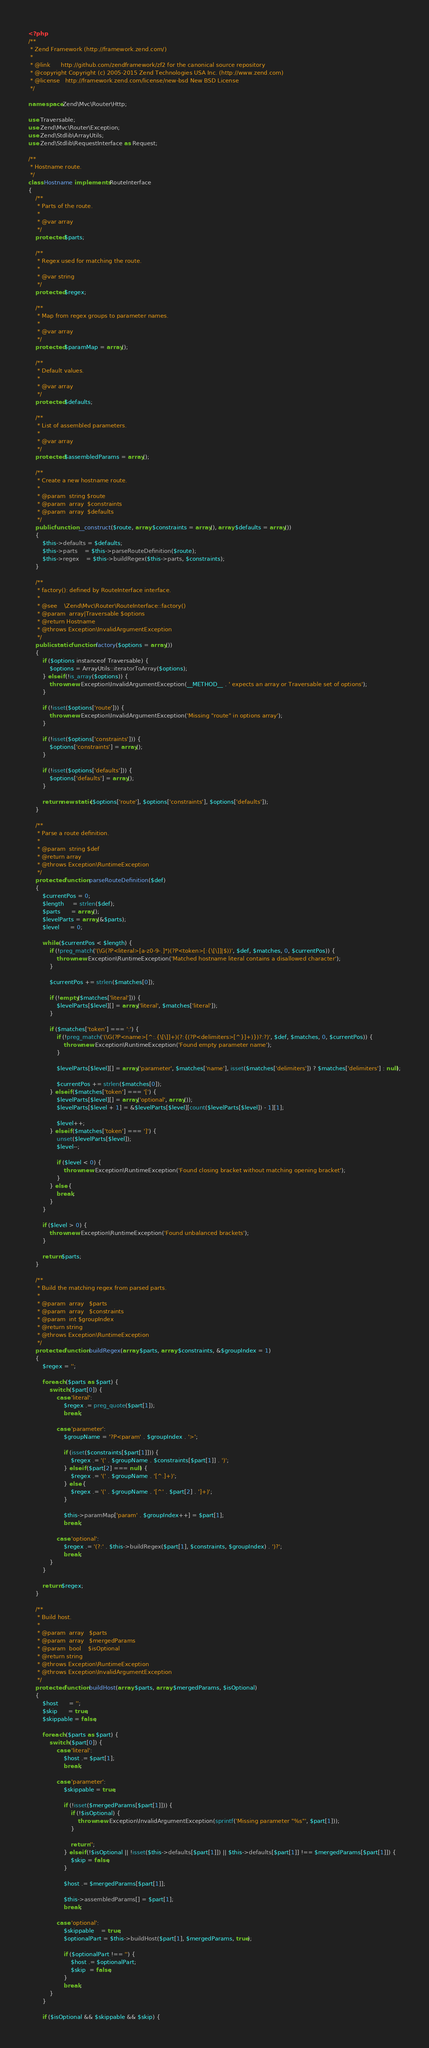<code> <loc_0><loc_0><loc_500><loc_500><_PHP_><?php
/**
 * Zend Framework (http://framework.zend.com/)
 *
 * @link      http://github.com/zendframework/zf2 for the canonical source repository
 * @copyright Copyright (c) 2005-2015 Zend Technologies USA Inc. (http://www.zend.com)
 * @license   http://framework.zend.com/license/new-bsd New BSD License
 */

namespace Zend\Mvc\Router\Http;

use Traversable;
use Zend\Mvc\Router\Exception;
use Zend\Stdlib\ArrayUtils;
use Zend\Stdlib\RequestInterface as Request;

/**
 * Hostname route.
 */
class Hostname implements RouteInterface
{
    /**
     * Parts of the route.
     *
     * @var array
     */
    protected $parts;

    /**
     * Regex used for matching the route.
     *
     * @var string
     */
    protected $regex;

    /**
     * Map from regex groups to parameter names.
     *
     * @var array
     */
    protected $paramMap = array();

    /**
     * Default values.
     *
     * @var array
     */
    protected $defaults;

    /**
     * List of assembled parameters.
     *
     * @var array
     */
    protected $assembledParams = array();

    /**
     * Create a new hostname route.
     *
     * @param  string $route
     * @param  array  $constraints
     * @param  array  $defaults
     */
    public function __construct($route, array $constraints = array(), array $defaults = array())
    {
        $this->defaults = $defaults;
        $this->parts    = $this->parseRouteDefinition($route);
        $this->regex    = $this->buildRegex($this->parts, $constraints);
    }

    /**
     * factory(): defined by RouteInterface interface.
     *
     * @see    \Zend\Mvc\Router\RouteInterface::factory()
     * @param  array|Traversable $options
     * @return Hostname
     * @throws Exception\InvalidArgumentException
     */
    public static function factory($options = array())
    {
        if ($options instanceof Traversable) {
            $options = ArrayUtils::iteratorToArray($options);
        } elseif (!is_array($options)) {
            throw new Exception\InvalidArgumentException(__METHOD__ . ' expects an array or Traversable set of options');
        }

        if (!isset($options['route'])) {
            throw new Exception\InvalidArgumentException('Missing "route" in options array');
        }

        if (!isset($options['constraints'])) {
            $options['constraints'] = array();
        }

        if (!isset($options['defaults'])) {
            $options['defaults'] = array();
        }

        return new static($options['route'], $options['constraints'], $options['defaults']);
    }

    /**
     * Parse a route definition.
     *
     * @param  string $def
     * @return array
     * @throws Exception\RuntimeException
     */
    protected function parseRouteDefinition($def)
    {
        $currentPos = 0;
        $length     = strlen($def);
        $parts      = array();
        $levelParts = array(&$parts);
        $level      = 0;

        while ($currentPos < $length) {
            if (!preg_match('(\G(?P<literal>[a-z0-9-.]*)(?P<token>[:{\[\]]|$))', $def, $matches, 0, $currentPos)) {
                throw new Exception\RuntimeException('Matched hostname literal contains a disallowed character');
            }

            $currentPos += strlen($matches[0]);

            if (!empty($matches['literal'])) {
                $levelParts[$level][] = array('literal', $matches['literal']);
            }

            if ($matches['token'] === ':') {
                if (!preg_match('(\G(?P<name>[^:.{\[\]]+)(?:{(?P<delimiters>[^}]+)})?:?)', $def, $matches, 0, $currentPos)) {
                    throw new Exception\RuntimeException('Found empty parameter name');
                }

                $levelParts[$level][] = array('parameter', $matches['name'], isset($matches['delimiters']) ? $matches['delimiters'] : null);

                $currentPos += strlen($matches[0]);
            } elseif ($matches['token'] === '[') {
                $levelParts[$level][] = array('optional', array());
                $levelParts[$level + 1] = &$levelParts[$level][count($levelParts[$level]) - 1][1];

                $level++;
            } elseif ($matches['token'] === ']') {
                unset($levelParts[$level]);
                $level--;

                if ($level < 0) {
                    throw new Exception\RuntimeException('Found closing bracket without matching opening bracket');
                }
            } else {
                break;
            }
        }

        if ($level > 0) {
            throw new Exception\RuntimeException('Found unbalanced brackets');
        }

        return $parts;
    }

    /**
     * Build the matching regex from parsed parts.
     *
     * @param  array   $parts
     * @param  array   $constraints
     * @param  int $groupIndex
     * @return string
     * @throws Exception\RuntimeException
     */
    protected function buildRegex(array $parts, array $constraints, &$groupIndex = 1)
    {
        $regex = '';

        foreach ($parts as $part) {
            switch ($part[0]) {
                case 'literal':
                    $regex .= preg_quote($part[1]);
                    break;

                case 'parameter':
                    $groupName = '?P<param' . $groupIndex . '>';

                    if (isset($constraints[$part[1]])) {
                        $regex .= '(' . $groupName . $constraints[$part[1]] . ')';
                    } elseif ($part[2] === null) {
                        $regex .= '(' . $groupName . '[^.]+)';
                    } else {
                        $regex .= '(' . $groupName . '[^' . $part[2] . ']+)';
                    }

                    $this->paramMap['param' . $groupIndex++] = $part[1];
                    break;

                case 'optional':
                    $regex .= '(?:' . $this->buildRegex($part[1], $constraints, $groupIndex) . ')?';
                    break;
            }
        }

        return $regex;
    }

    /**
     * Build host.
     *
     * @param  array   $parts
     * @param  array   $mergedParams
     * @param  bool    $isOptional
     * @return string
     * @throws Exception\RuntimeException
     * @throws Exception\InvalidArgumentException
     */
    protected function buildHost(array $parts, array $mergedParams, $isOptional)
    {
        $host      = '';
        $skip      = true;
        $skippable = false;

        foreach ($parts as $part) {
            switch ($part[0]) {
                case 'literal':
                    $host .= $part[1];
                    break;

                case 'parameter':
                    $skippable = true;

                    if (!isset($mergedParams[$part[1]])) {
                        if (!$isOptional) {
                            throw new Exception\InvalidArgumentException(sprintf('Missing parameter "%s"', $part[1]));
                        }

                        return '';
                    } elseif (!$isOptional || !isset($this->defaults[$part[1]]) || $this->defaults[$part[1]] !== $mergedParams[$part[1]]) {
                        $skip = false;
                    }

                    $host .= $mergedParams[$part[1]];

                    $this->assembledParams[] = $part[1];
                    break;

                case 'optional':
                    $skippable    = true;
                    $optionalPart = $this->buildHost($part[1], $mergedParams, true);

                    if ($optionalPart !== '') {
                        $host .= $optionalPart;
                        $skip  = false;
                    }
                    break;
            }
        }

        if ($isOptional && $skippable && $skip) {</code> 